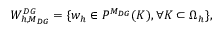Convert formula to latex. <formula><loc_0><loc_0><loc_500><loc_500>W _ { h , M _ { D G } } ^ { D G } = \{ w _ { h } \in P ^ { M _ { D G } } ( K ) , \forall K \subset \Omega _ { h } \} ,</formula> 